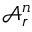Convert formula to latex. <formula><loc_0><loc_0><loc_500><loc_500>\mathcal { A } _ { r } ^ { n }</formula> 